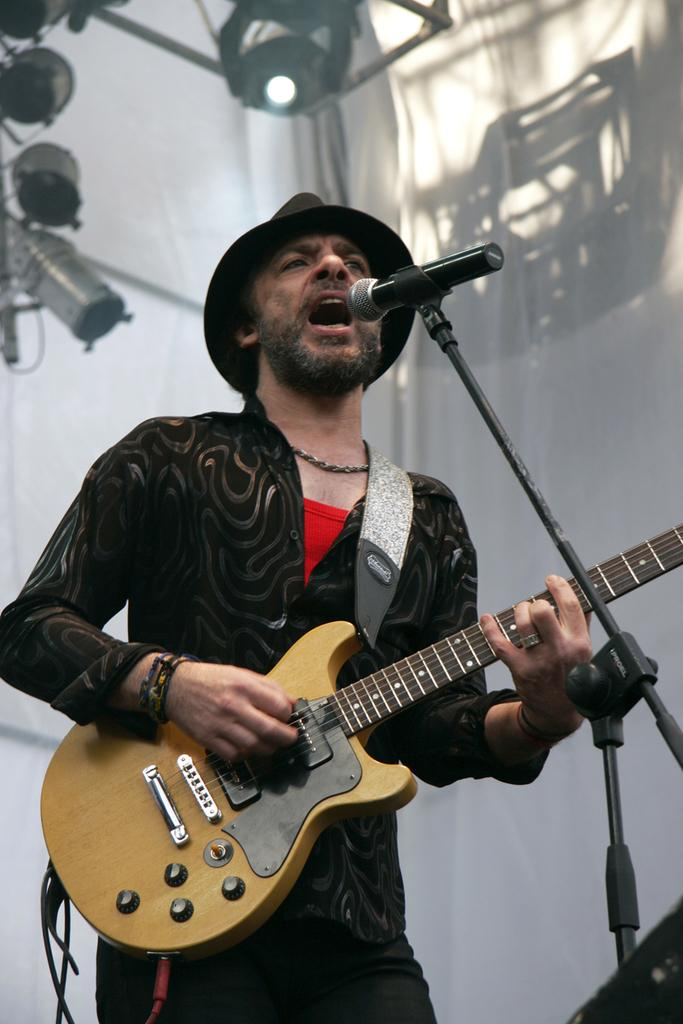What is the man in the image doing? The man is playing the guitar and singing on a microphone. What instrument is the man holding? The man is holding a guitar. What can be seen in the background of the image? There are cloth-like objects and lights in the background. What type of credit system is being used by the man in the image? There is no credit system mentioned or depicted in the image; the man is simply playing the guitar and singing on a microphone. 